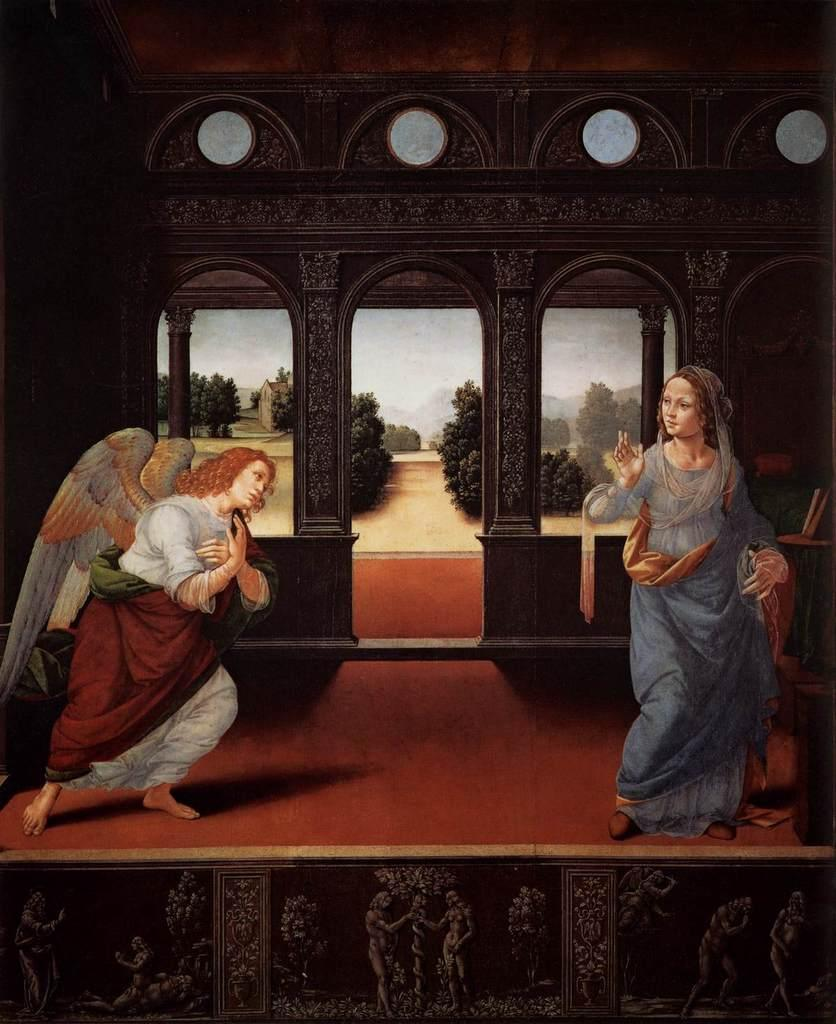What is the main subject of the image? There is a painting in the image. What is depicted in the painting? The painting depicts two ladies. Where are the ladies located in the painting? The ladies are standing on a stage. What is unique about one of the ladies' appearance? One of the ladies is wearing wings on her shoulder. What can be seen in the background of the painting? There is a wall and trees in the background of the painting. What type of science is being conducted on the stage in the image? There is no indication of any scientific activity being conducted in the image; it depicts two ladies on a stage. What boundary is visible in the image? There is no boundary visible in the image; it features a painting of two ladies on a stage with a background of a wall and trees. 